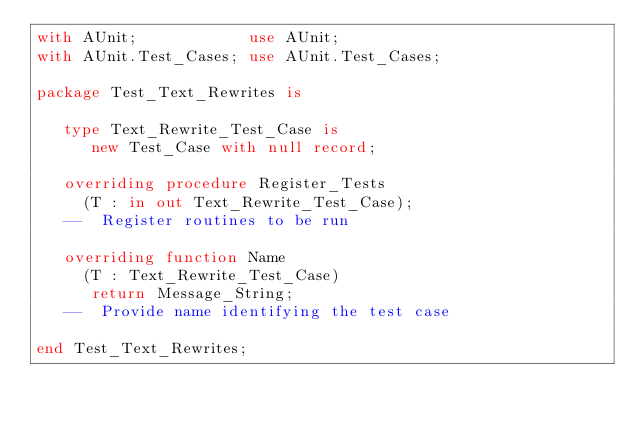Convert code to text. <code><loc_0><loc_0><loc_500><loc_500><_Ada_>with AUnit;            use AUnit;
with AUnit.Test_Cases; use AUnit.Test_Cases;

package Test_Text_Rewrites is

   type Text_Rewrite_Test_Case is
      new Test_Case with null record;

   overriding procedure Register_Tests
     (T : in out Text_Rewrite_Test_Case);
   --  Register routines to be run

   overriding function Name
     (T : Text_Rewrite_Test_Case)
      return Message_String;
   --  Provide name identifying the test case

end Test_Text_Rewrites;
</code> 